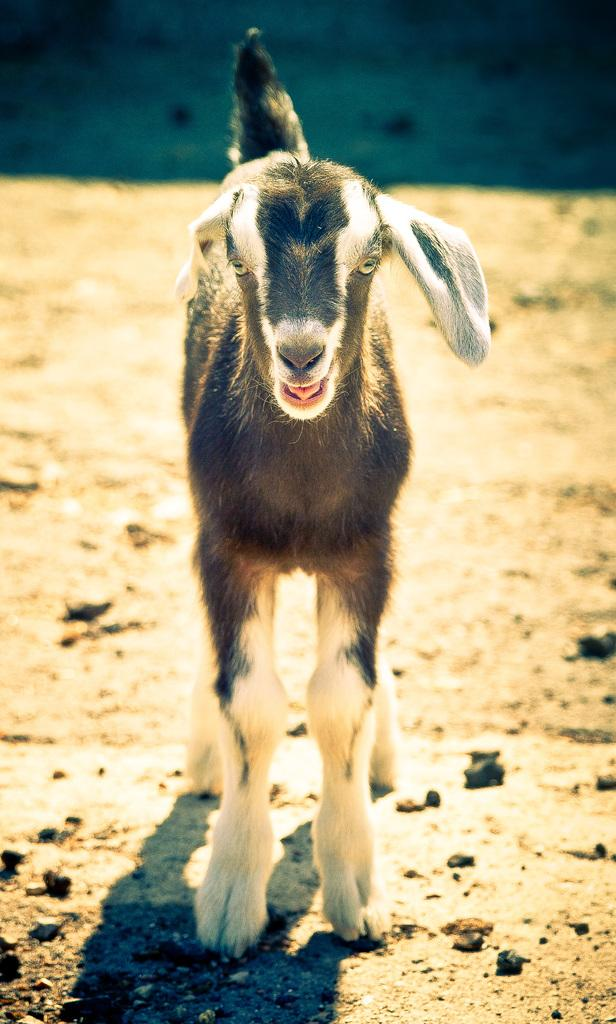What animal is the main subject of the picture? There is a goat in the picture. Can you describe the background of the image? The background of the image is blurred. How many crows are sitting on the chairs in the image? There are no crows or chairs present in the image; it features a goat with a blurred background. 